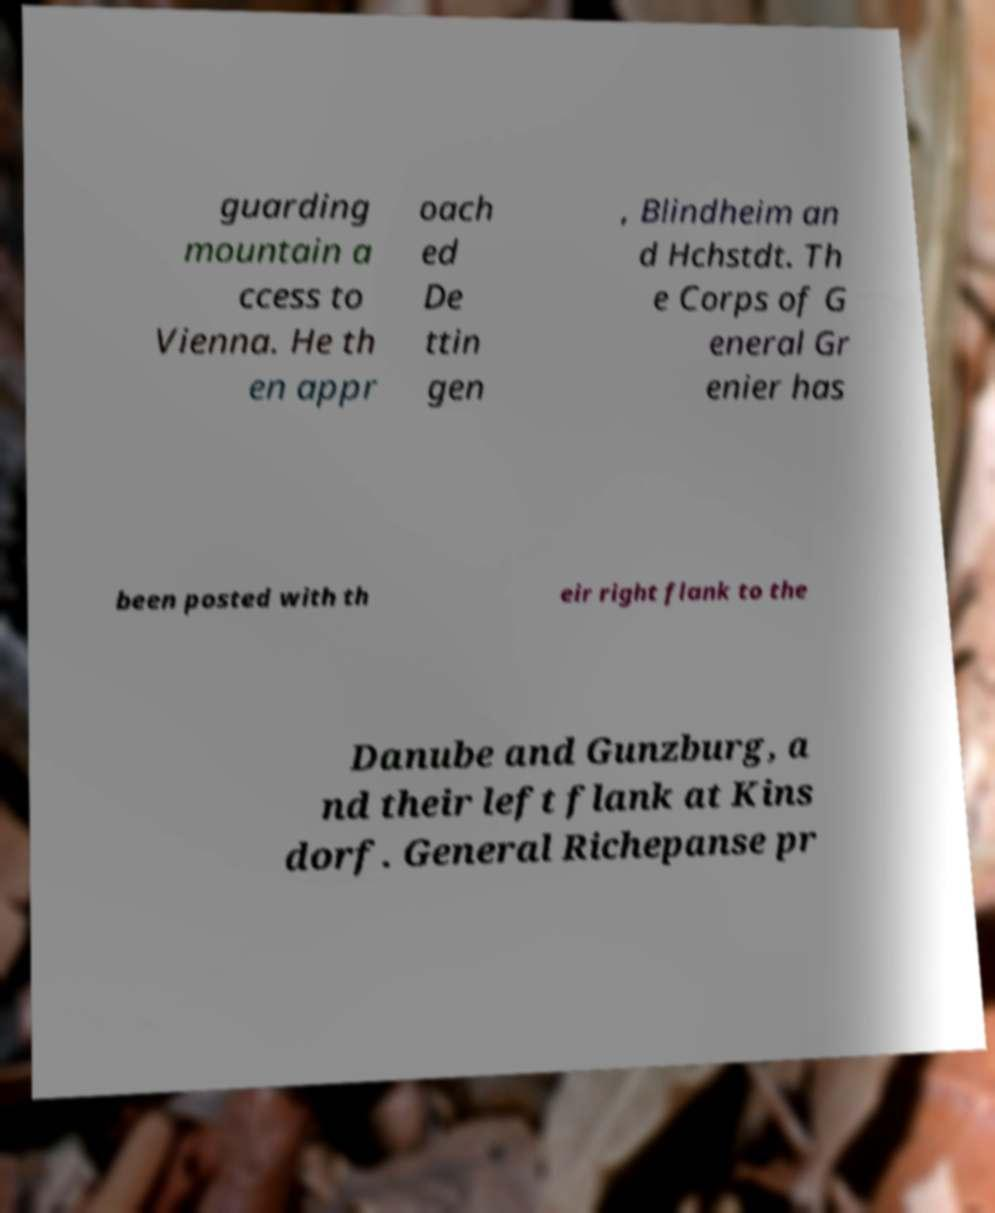There's text embedded in this image that I need extracted. Can you transcribe it verbatim? guarding mountain a ccess to Vienna. He th en appr oach ed De ttin gen , Blindheim an d Hchstdt. Th e Corps of G eneral Gr enier has been posted with th eir right flank to the Danube and Gunzburg, a nd their left flank at Kins dorf. General Richepanse pr 